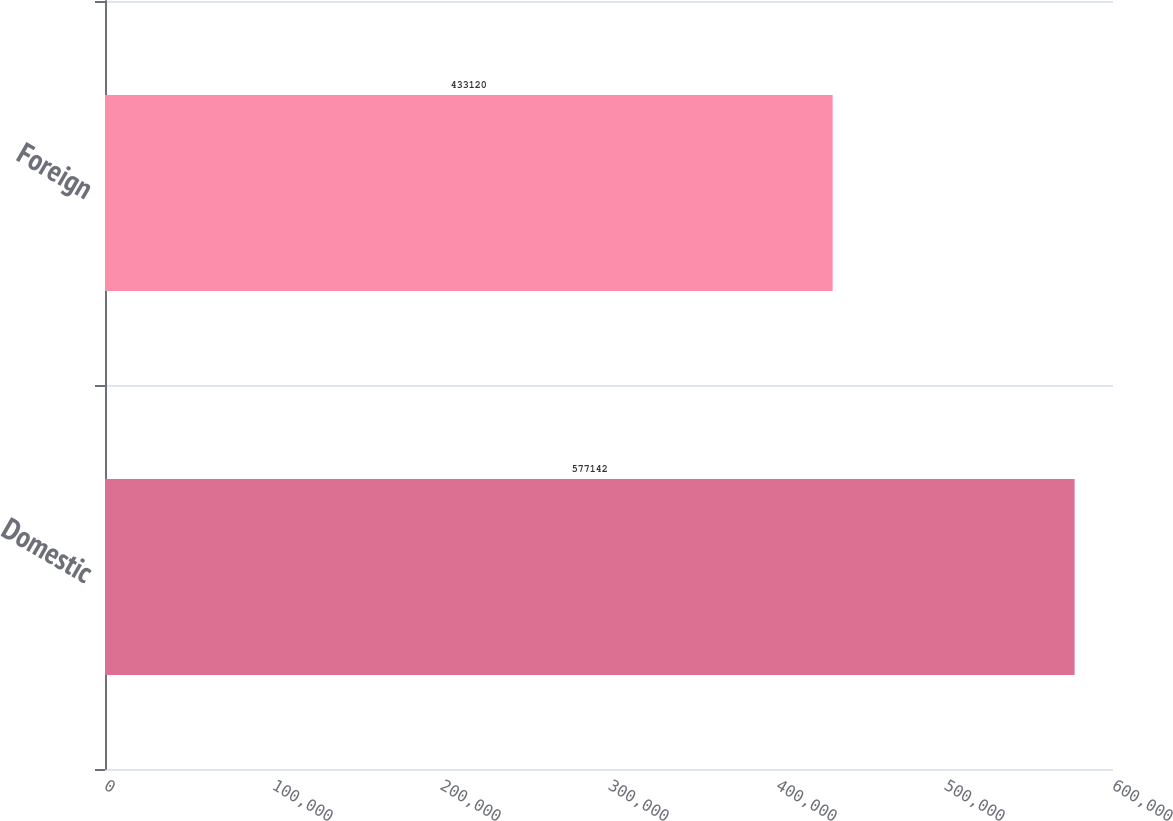<chart> <loc_0><loc_0><loc_500><loc_500><bar_chart><fcel>Domestic<fcel>Foreign<nl><fcel>577142<fcel>433120<nl></chart> 